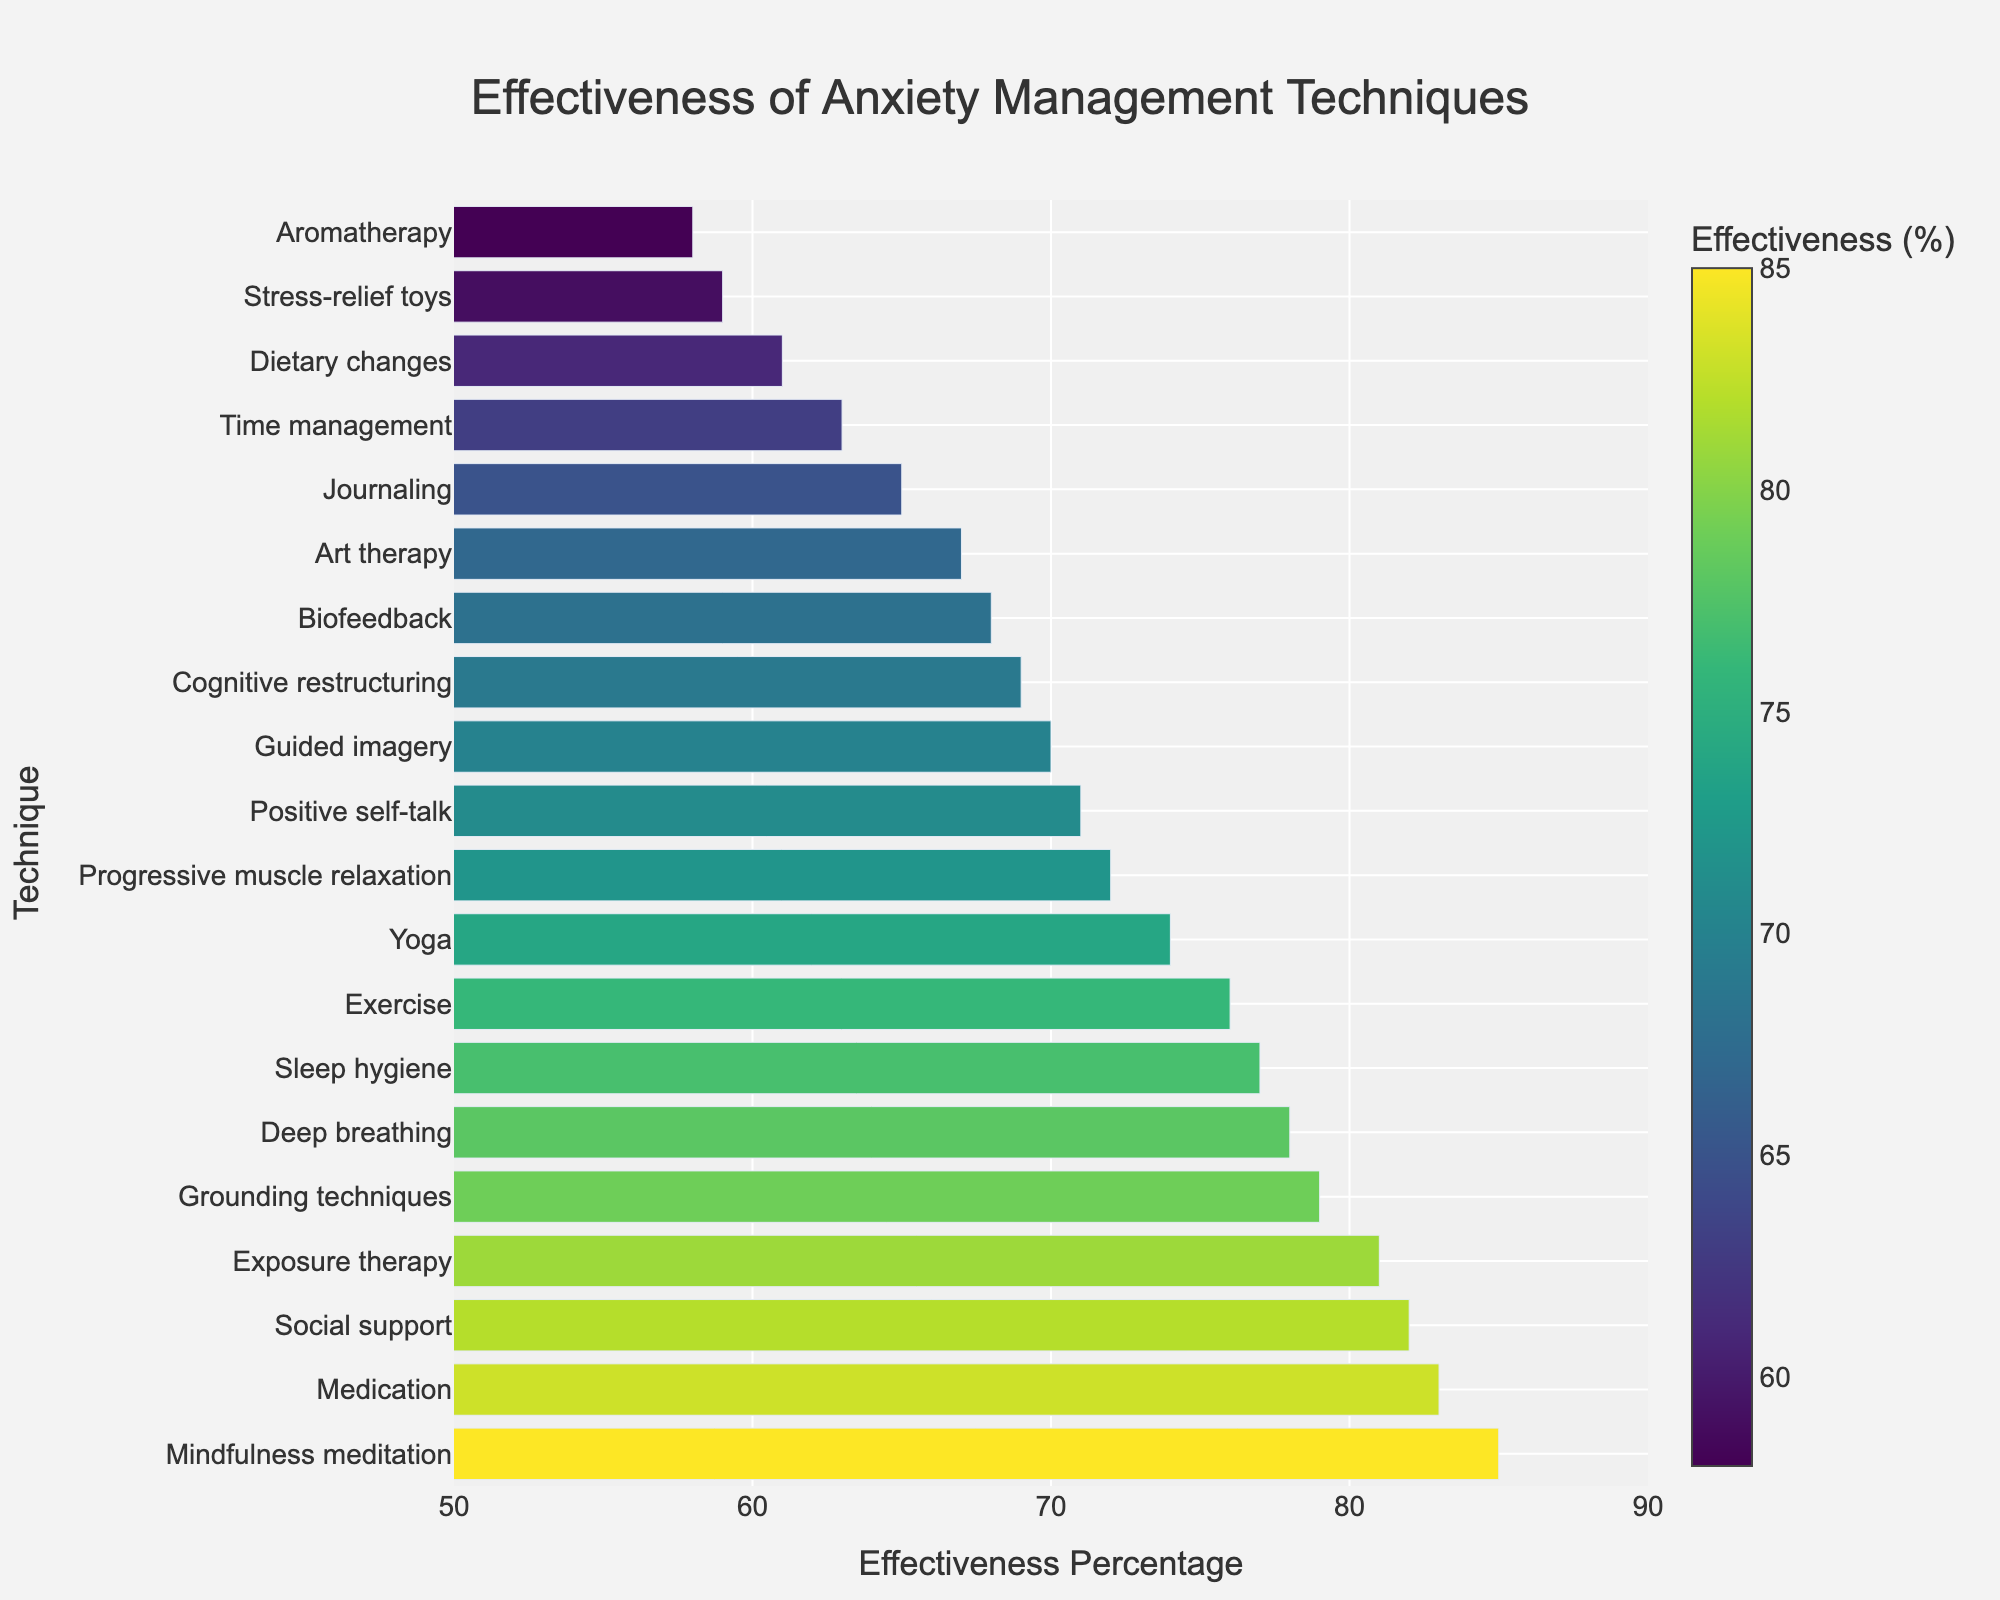what is the most effective anxiety management technique? The chart shows that Mindfulness meditation has the highest effectiveness percentage at 85%, which is the tallest bar.
Answer: Mindfulness meditation which anxiety management technique has a higher effectiveness, Exercise or Yoga? The chart indicates that Exercise has an effectiveness of 76% and Yoga has an effectiveness of 74%. Exercise's effectiveness percentage is higher than that of Yoga.
Answer: Exercise what is the difference in effectiveness between Deep breathing and Cognitive restructuring? The chart shows that Deep breathing has an effectiveness of 78% and Cognitive restructuring has 69%. Subtracting 69% from 78% gives a difference of 9%.
Answer: 9% which technique is less effective, Journaling or Guided imagery? According to the chart, Journaling has an effectiveness of 65% while Guided imagery has 70%. Journaling is less effective.
Answer: Journaling what is the average effectiveness of the techniques Social support, Medication, and Exposure therapy? Social support has 82%, Medication has 83%, and Exposure therapy has 81%. Summing these gives 82 + 83 + 81 = 246. Dividing by 3 gives an average of 82%.
Answer: 82% which techniques have an effectiveness higher than 80%? The chart indicates Mindfulness meditation (85%), Exposure therapy (81%), Social support (82%), and Medication (83%) have effectiveness percentages higher than 80%.
Answer: Mindfulness meditation, Exposure therapy, Social support, Medication which technique has the lowest effectiveness? The chart shows that Aromatherapy has an effectiveness percentage of 58%, which is the shortest bar and thus the lowest effectiveness.
Answer: Aromatherapy how many techniques have an effectiveness percentage between 70% and 80%, inclusive? The chart shows that Progressive muscle relaxation (72%), Guided imagery (70%), Yoga (74%), Positive self-talk (71%), Grounding techniques (79%), Deep breathing (78%), and Exercise (76%) all have effectiveness percentages within the 70% to 80% range. Counting these gives 7 techniques.
Answer: 7 what is the total effectiveness percentage of Art therapy, Guided imagery, and Stress-relief toys? Art therapy has 67%, Guided imagery has 70%, and Stress-relief toys have 59%. Adding these gives 67 + 70 + 59 = 196.
Answer: 196% which techniques have an effectiveness percentage of equal to or higher than 75% and lower than 80%? The chart indicates that Deep breathing (78%), Exercise (76%), Grounding techniques (79%), and Sleep hygiene (77%) fall within the range of 75% to 80%.
Answer: Deep breathing, Exercise, Grounding techniques, Sleep hygiene 